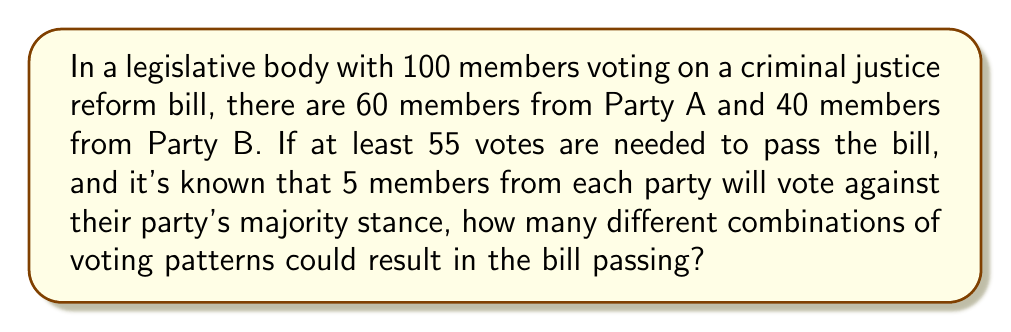Teach me how to tackle this problem. Let's approach this step-by-step:

1) First, we need to determine the majority stance of each party:
   - Party A (60 members): 55 for, 5 against
   - Party B (40 members): 35 against, 5 for

2) The bill needs at least 55 votes to pass. We start with 60 potential "yes" votes (55 from Party A + 5 from Party B).

3) To find the number of combinations that result in the bill passing, we need to calculate how many ways we can select 0 to 5 "no" votes from the 55 Party A members who are voting "yes", while still having at least 55 total "yes" votes.

4) We can use the combination formula for each scenario:

   $$\binom{n}{r} = \frac{n!}{r!(n-r)!}$$

   Where $n$ is the total number of items and $r$ is the number of items being chosen.

5) Let's calculate each possibility:
   - 0 Party A members vote "no": $\binom{55}{0} = 1$
   - 1 Party A member votes "no":  $\binom{55}{1} = 55$
   - 2 Party A members vote "no": $\binom{55}{2} = 1485$
   - 3 Party A members vote "no": $\binom{55}{3} = 26235$
   - 4 Party A members vote "no": $\binom{55}{4} = 341055$
   - 5 Party A members vote "no": $\binom{55}{5} = 3478761$

6) The total number of possible combinations is the sum of all these:

   $$1 + 55 + 1485 + 26235 + 341055 + 3478761 = 3847592$$

Therefore, there are 3,847,592 different combinations of voting patterns that could result in the bill passing.
Answer: 3,847,592 